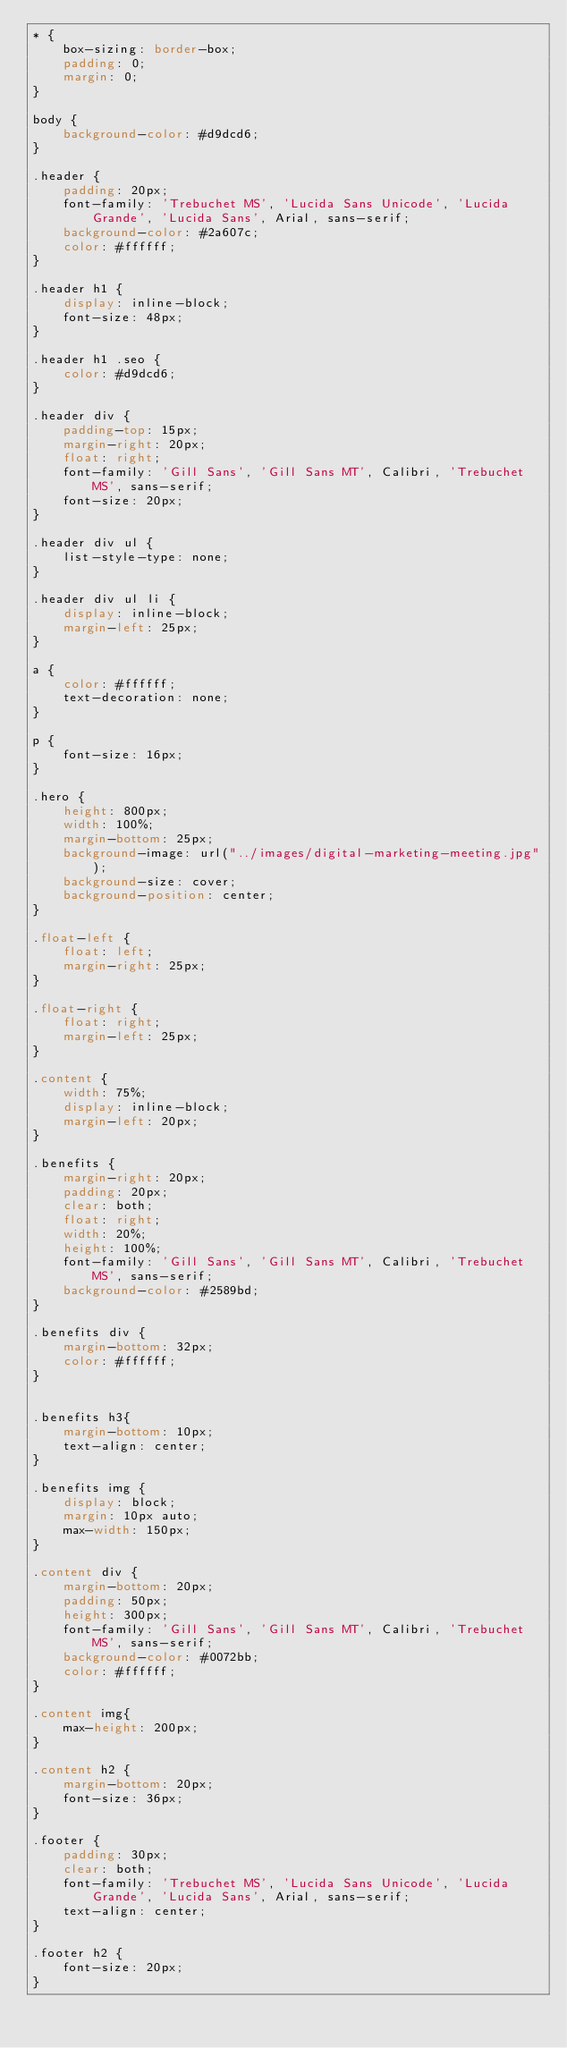Convert code to text. <code><loc_0><loc_0><loc_500><loc_500><_CSS_>* {
    box-sizing: border-box;
    padding: 0;
    margin: 0;
}

body {
    background-color: #d9dcd6;
}

.header {
    padding: 20px;
    font-family: 'Trebuchet MS', 'Lucida Sans Unicode', 'Lucida Grande', 'Lucida Sans', Arial, sans-serif;
    background-color: #2a607c;
    color: #ffffff;
}

.header h1 {
    display: inline-block;
    font-size: 48px;
}

.header h1 .seo {
    color: #d9dcd6;
}

.header div {
    padding-top: 15px;
    margin-right: 20px;
    float: right;
    font-family: 'Gill Sans', 'Gill Sans MT', Calibri, 'Trebuchet MS', sans-serif;
    font-size: 20px;
}

.header div ul {
    list-style-type: none;
}

.header div ul li {
    display: inline-block;
    margin-left: 25px;
}

a {
    color: #ffffff;
    text-decoration: none;
}

p {
    font-size: 16px;
}

.hero {
    height: 800px;
    width: 100%;
    margin-bottom: 25px;
    background-image: url("../images/digital-marketing-meeting.jpg");
    background-size: cover;
    background-position: center;
}

.float-left {
    float: left;
    margin-right: 25px;
}

.float-right {
    float: right;
    margin-left: 25px;
}

.content {
    width: 75%;
    display: inline-block;
    margin-left: 20px;
}

.benefits {
    margin-right: 20px;
    padding: 20px;
    clear: both;
    float: right;
    width: 20%;
    height: 100%;
    font-family: 'Gill Sans', 'Gill Sans MT', Calibri, 'Trebuchet MS', sans-serif;
    background-color: #2589bd;
}

.benefits div {
    margin-bottom: 32px;
    color: #ffffff;
}


.benefits h3{
    margin-bottom: 10px;
    text-align: center;
}

.benefits img {
    display: block;
    margin: 10px auto;
    max-width: 150px;
}

.content div {
    margin-bottom: 20px;
    padding: 50px;
    height: 300px;
    font-family: 'Gill Sans', 'Gill Sans MT', Calibri, 'Trebuchet MS', sans-serif;
    background-color: #0072bb;
    color: #ffffff;
}

.content img{
    max-height: 200px;
}

.content h2 {
    margin-bottom: 20px;
    font-size: 36px;
}

.footer {
    padding: 30px;
    clear: both;
    font-family: 'Trebuchet MS', 'Lucida Sans Unicode', 'Lucida Grande', 'Lucida Sans', Arial, sans-serif;
    text-align: center;
}

.footer h2 {
    font-size: 20px;
}
</code> 